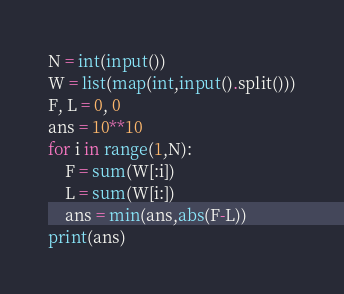Convert code to text. <code><loc_0><loc_0><loc_500><loc_500><_Python_>N = int(input())
W = list(map(int,input().split()))
F, L = 0, 0
ans = 10**10
for i in range(1,N):
    F = sum(W[:i])
    L = sum(W[i:])
    ans = min(ans,abs(F-L))
print(ans)
</code> 